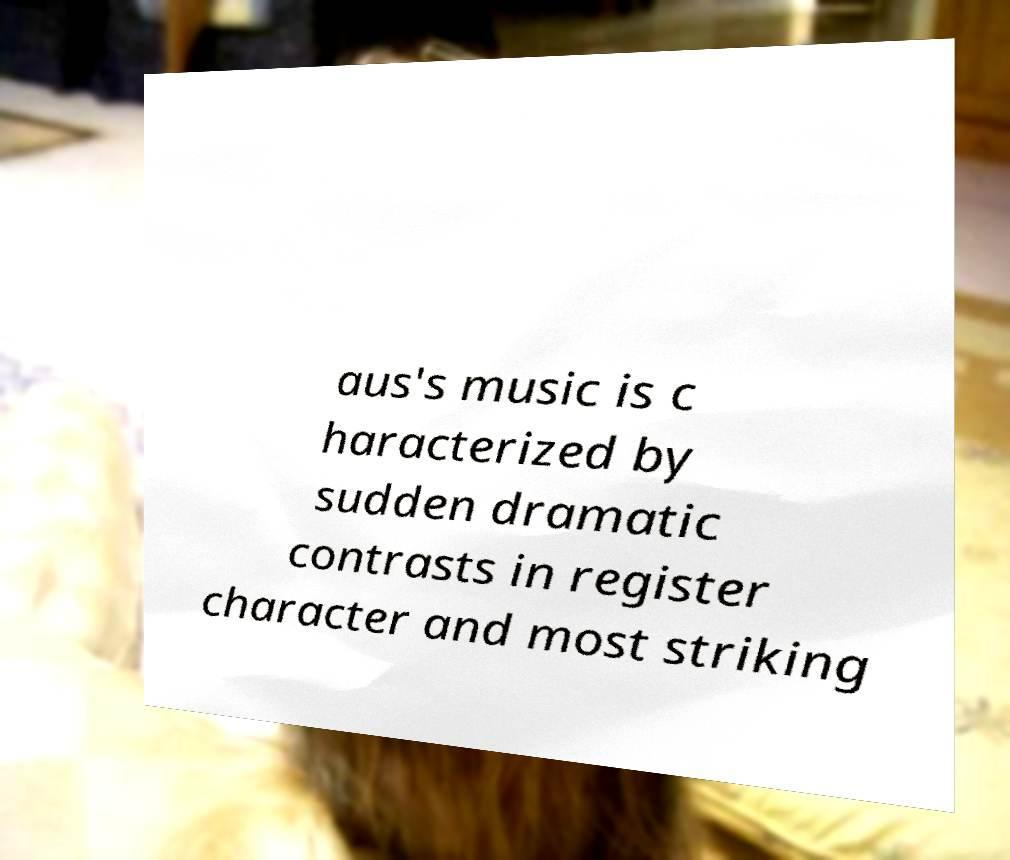Please read and relay the text visible in this image. What does it say? aus's music is c haracterized by sudden dramatic contrasts in register character and most striking 